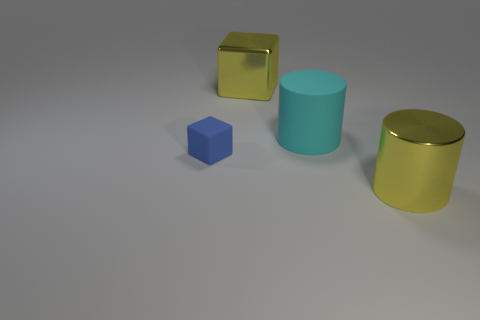Are there more large cyan things that are left of the small blue matte cube than small cubes that are behind the large cyan rubber thing? Based on the image, the number of large cyan things to the left of the small blue matte cube is one, and there are no small cubes behind any large cyan rubber things. Therefore, the answer to your question is yes, because there is at least one large cyan thing left of the small blue cube, but there are no small cubes behind the large cyan object. 